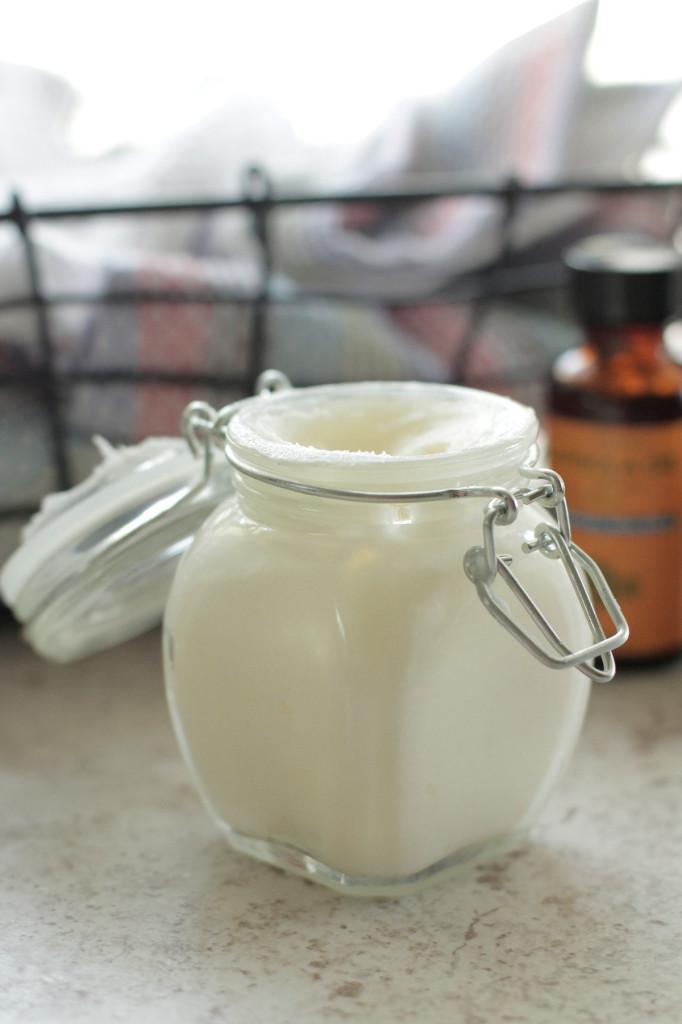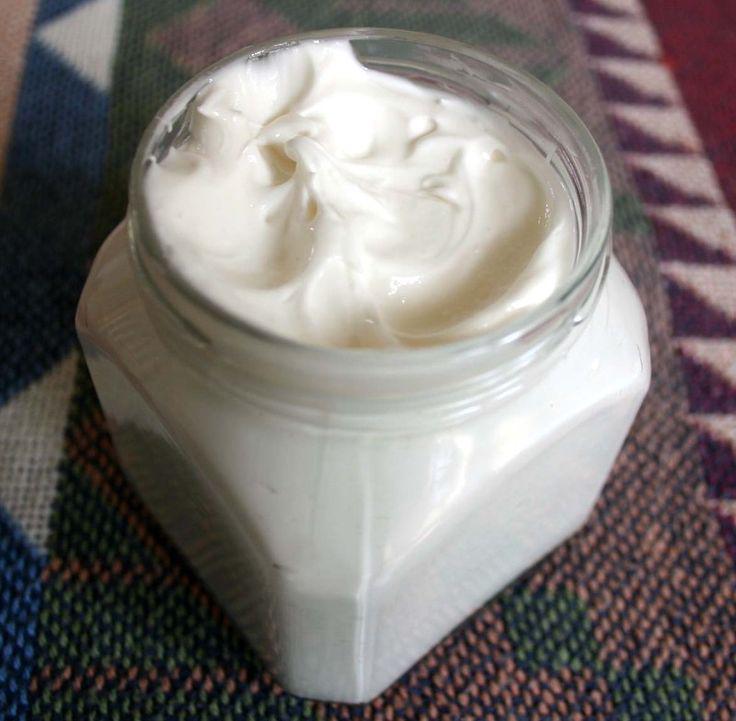The first image is the image on the left, the second image is the image on the right. Evaluate the accuracy of this statement regarding the images: "Left and right images show similarly-shaped clear glass open-topped jars containing a creamy substance.". Is it true? Answer yes or no. Yes. The first image is the image on the left, the second image is the image on the right. Considering the images on both sides, is "There are two glass jars and they are both open." valid? Answer yes or no. Yes. 